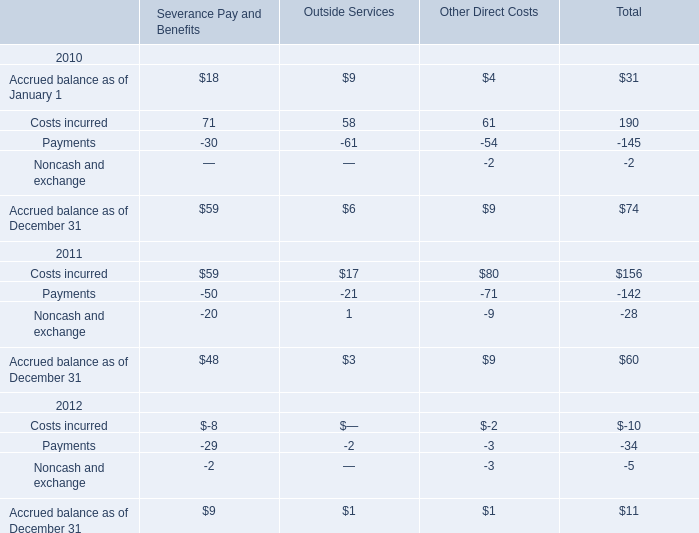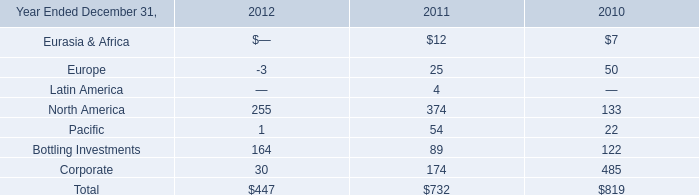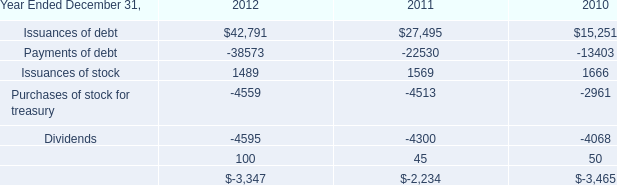What was the average of Costs incurred in 2011 for Severance Pay and Benefits,Outside Services, and Other Direct Costs ? 
Computations: (((59 + 17) + 80) / 3)
Answer: 52.0. 